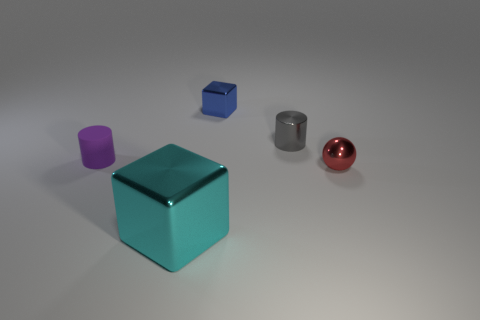How many red objects have the same shape as the gray metallic object?
Give a very brief answer. 0. How many objects are either purple matte cylinders or objects that are in front of the small blue shiny object?
Your answer should be very brief. 4. What is the small red thing made of?
Offer a very short reply. Metal. There is a purple object that is the same shape as the gray metal thing; what is it made of?
Your answer should be compact. Rubber. There is a metallic cube to the right of the metal object left of the blue cube; what color is it?
Offer a terse response. Blue. What number of metallic objects are big red balls or large cyan cubes?
Keep it short and to the point. 1. Does the tiny red thing have the same material as the gray thing?
Give a very brief answer. Yes. What is the material of the small cylinder right of the metallic cube that is behind the tiny red ball?
Ensure brevity in your answer.  Metal. What number of small things are gray cylinders or shiny blocks?
Your response must be concise. 2. What is the size of the red sphere?
Your answer should be compact. Small. 